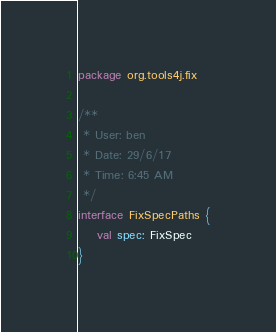Convert code to text. <code><loc_0><loc_0><loc_500><loc_500><_Kotlin_>package org.tools4j.fix

/**
 * User: ben
 * Date: 29/6/17
 * Time: 6:45 AM
 */
interface FixSpecPaths {
    val spec: FixSpec
}
</code> 